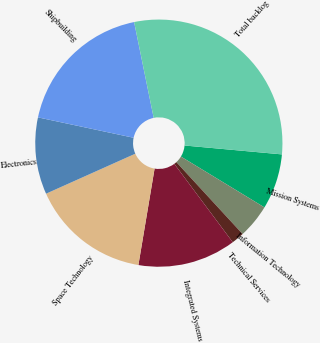Convert chart to OTSL. <chart><loc_0><loc_0><loc_500><loc_500><pie_chart><fcel>Mission Systems<fcel>Information Technology<fcel>Technical Services<fcel>Integrated Systems<fcel>Space Technology<fcel>Electronics<fcel>Shipbuilding<fcel>Total backlog<nl><fcel>7.25%<fcel>4.45%<fcel>1.65%<fcel>12.85%<fcel>15.65%<fcel>10.05%<fcel>18.45%<fcel>29.66%<nl></chart> 